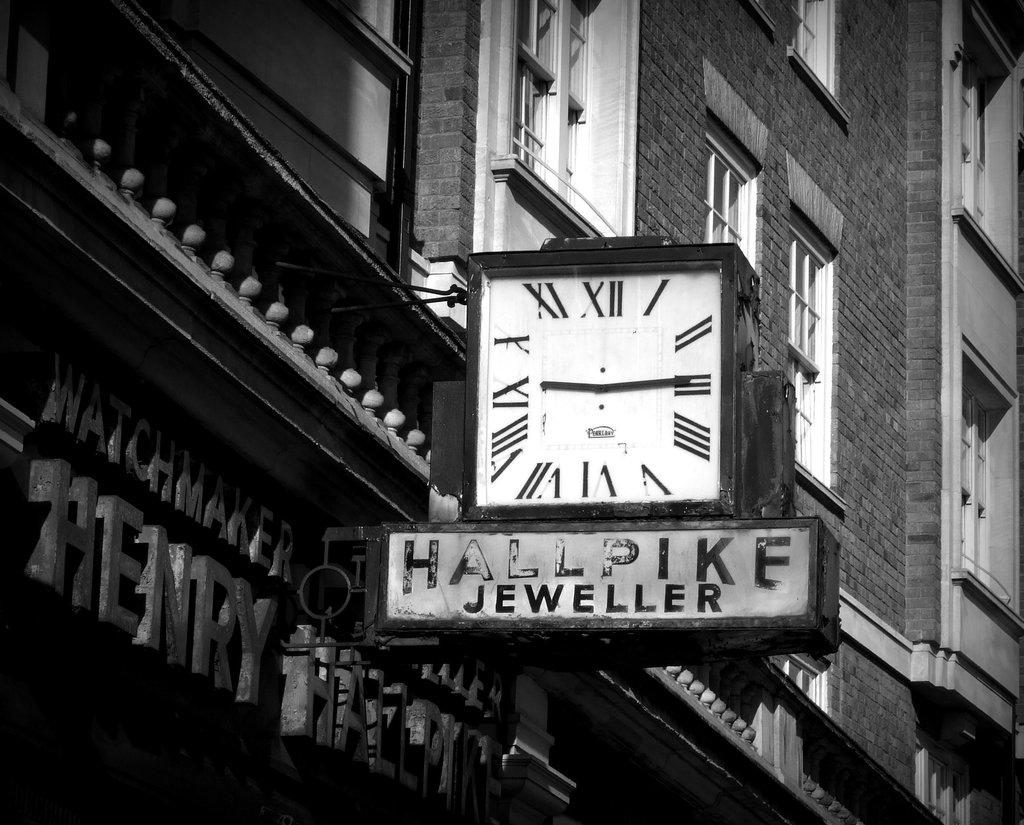<image>
Present a compact description of the photo's key features. a clock with the advertisement Hallpike Jeweller is on a building 